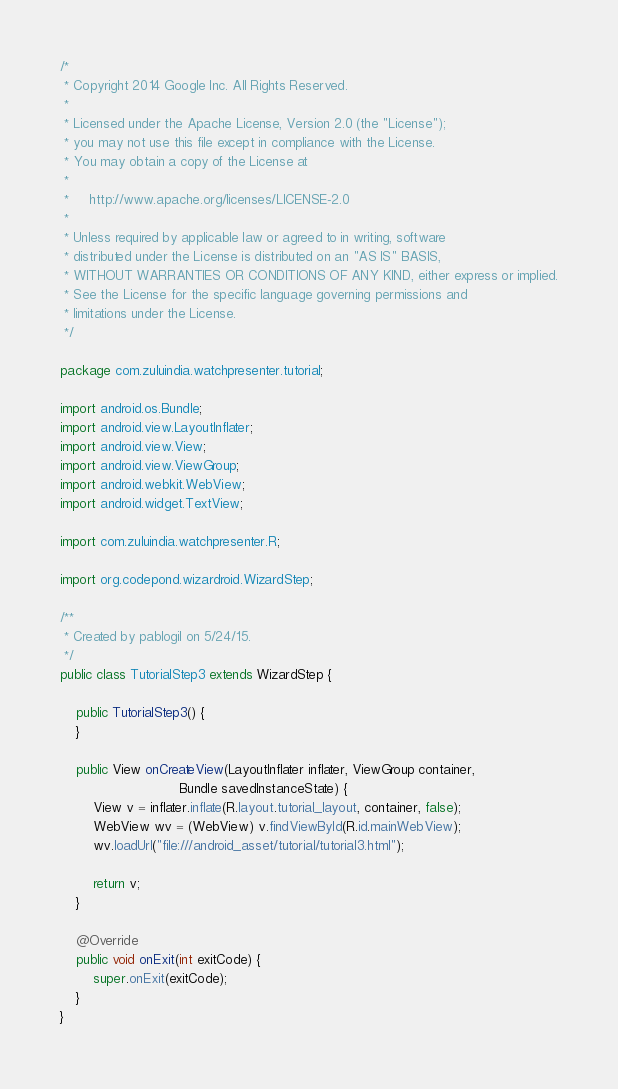<code> <loc_0><loc_0><loc_500><loc_500><_Java_>/*
 * Copyright 2014 Google Inc. All Rights Reserved.
 *
 * Licensed under the Apache License, Version 2.0 (the "License");
 * you may not use this file except in compliance with the License.
 * You may obtain a copy of the License at
 *
 *     http://www.apache.org/licenses/LICENSE-2.0
 *
 * Unless required by applicable law or agreed to in writing, software
 * distributed under the License is distributed on an "AS IS" BASIS,
 * WITHOUT WARRANTIES OR CONDITIONS OF ANY KIND, either express or implied.
 * See the License for the specific language governing permissions and
 * limitations under the License.
 */

package com.zuluindia.watchpresenter.tutorial;

import android.os.Bundle;
import android.view.LayoutInflater;
import android.view.View;
import android.view.ViewGroup;
import android.webkit.WebView;
import android.widget.TextView;

import com.zuluindia.watchpresenter.R;

import org.codepond.wizardroid.WizardStep;

/**
 * Created by pablogil on 5/24/15.
 */
public class TutorialStep3 extends WizardStep {

    public TutorialStep3() {
    }
    
    public View onCreateView(LayoutInflater inflater, ViewGroup container,
                             Bundle savedInstanceState) {
        View v = inflater.inflate(R.layout.tutorial_layout, container, false);
        WebView wv = (WebView) v.findViewById(R.id.mainWebView);
        wv.loadUrl("file:///android_asset/tutorial/tutorial3.html");

        return v;
    }

    @Override
    public void onExit(int exitCode) {
        super.onExit(exitCode);
    }
}
</code> 